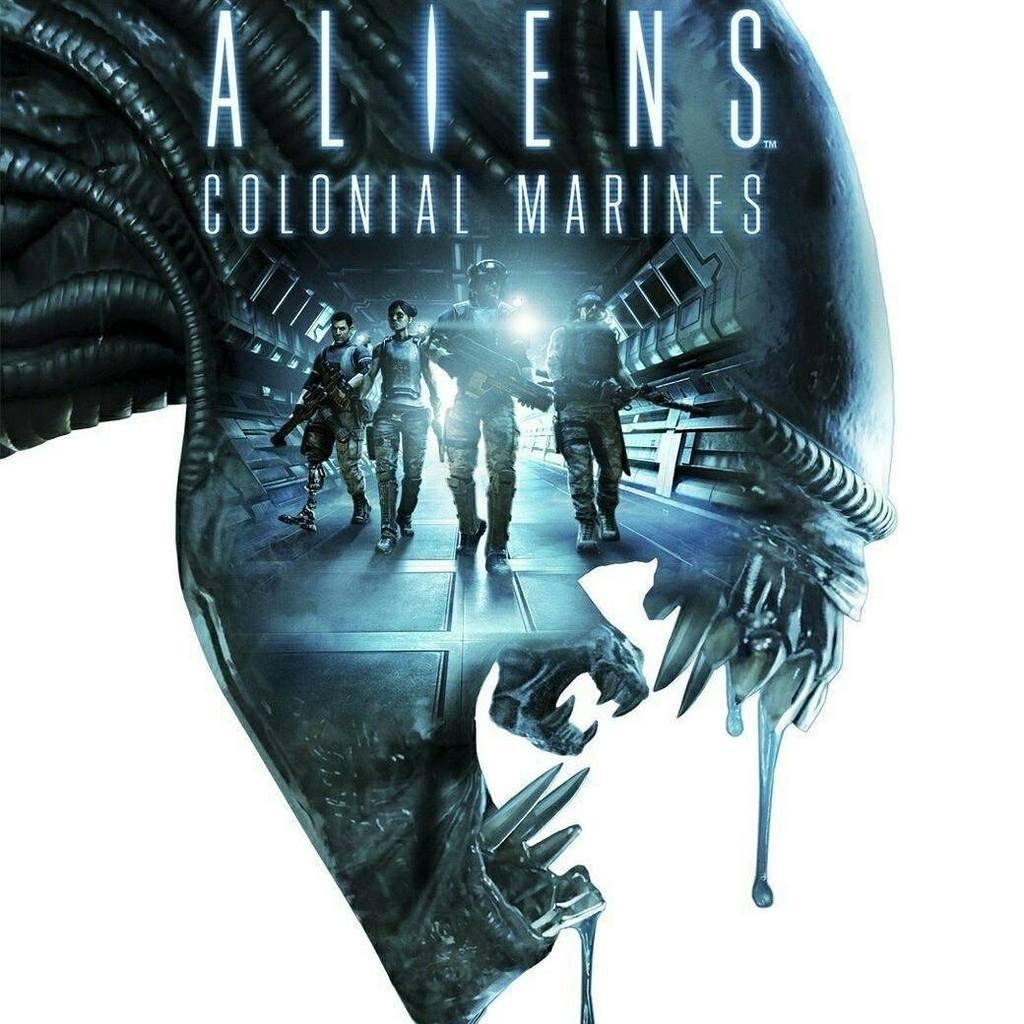Provide a one-sentence caption for the provided image. Poster showing four soldiers titled Aliens Colonial Marines. 